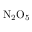Convert formula to latex. <formula><loc_0><loc_0><loc_500><loc_500>N _ { 2 } O _ { 5 }</formula> 